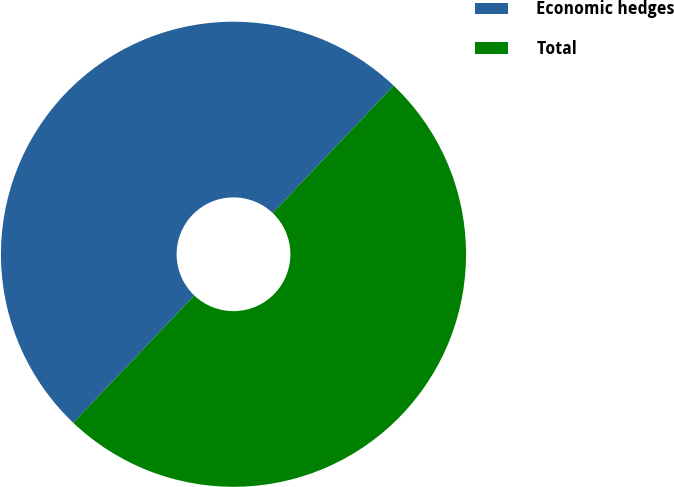Convert chart to OTSL. <chart><loc_0><loc_0><loc_500><loc_500><pie_chart><fcel>Economic hedges<fcel>Total<nl><fcel>49.99%<fcel>50.01%<nl></chart> 